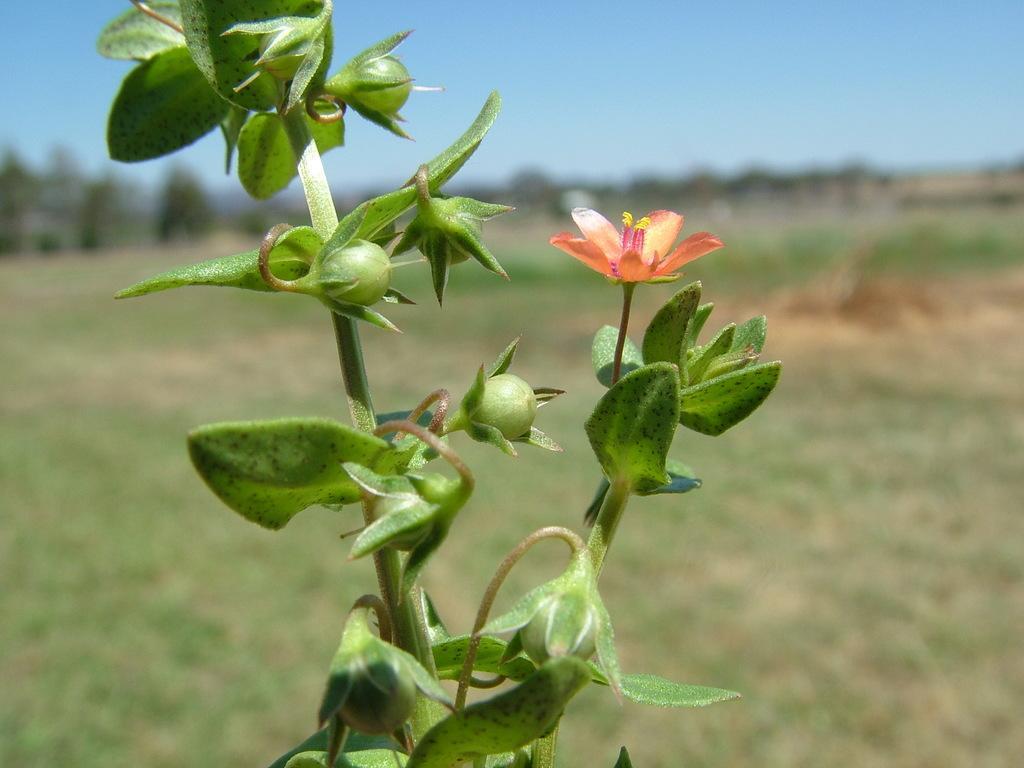In one or two sentences, can you explain what this image depicts? It is a plant. There is a flower in it. This is the sky at the top. 